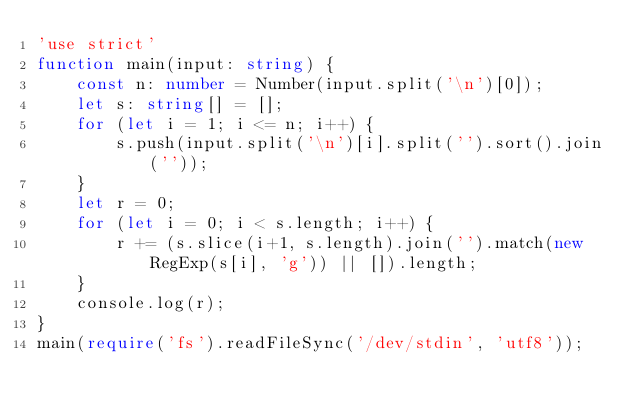Convert code to text. <code><loc_0><loc_0><loc_500><loc_500><_TypeScript_>'use strict'
function main(input: string) {
    const n: number = Number(input.split('\n')[0]);
    let s: string[] = [];
    for (let i = 1; i <= n; i++) {
        s.push(input.split('\n')[i].split('').sort().join(''));
    }
    let r = 0;
    for (let i = 0; i < s.length; i++) {
        r += (s.slice(i+1, s.length).join('').match(new RegExp(s[i], 'g')) || []).length;
    }
    console.log(r);
}
main(require('fs').readFileSync('/dev/stdin', 'utf8'));</code> 